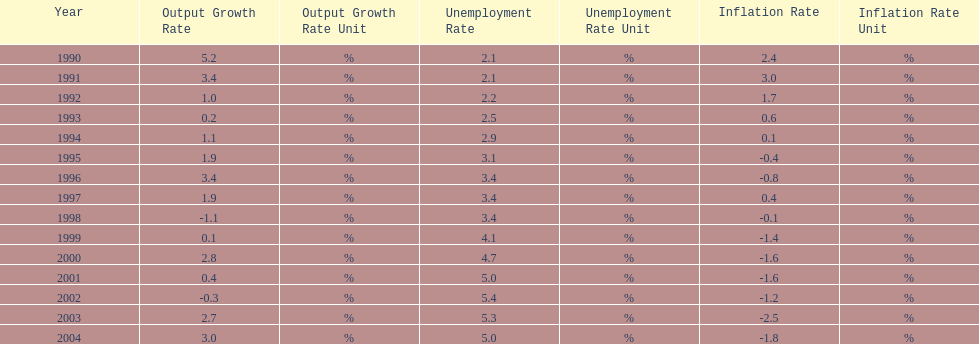What year saw the highest output growth rate in japan between the years 1990 and 2004? 1990. 